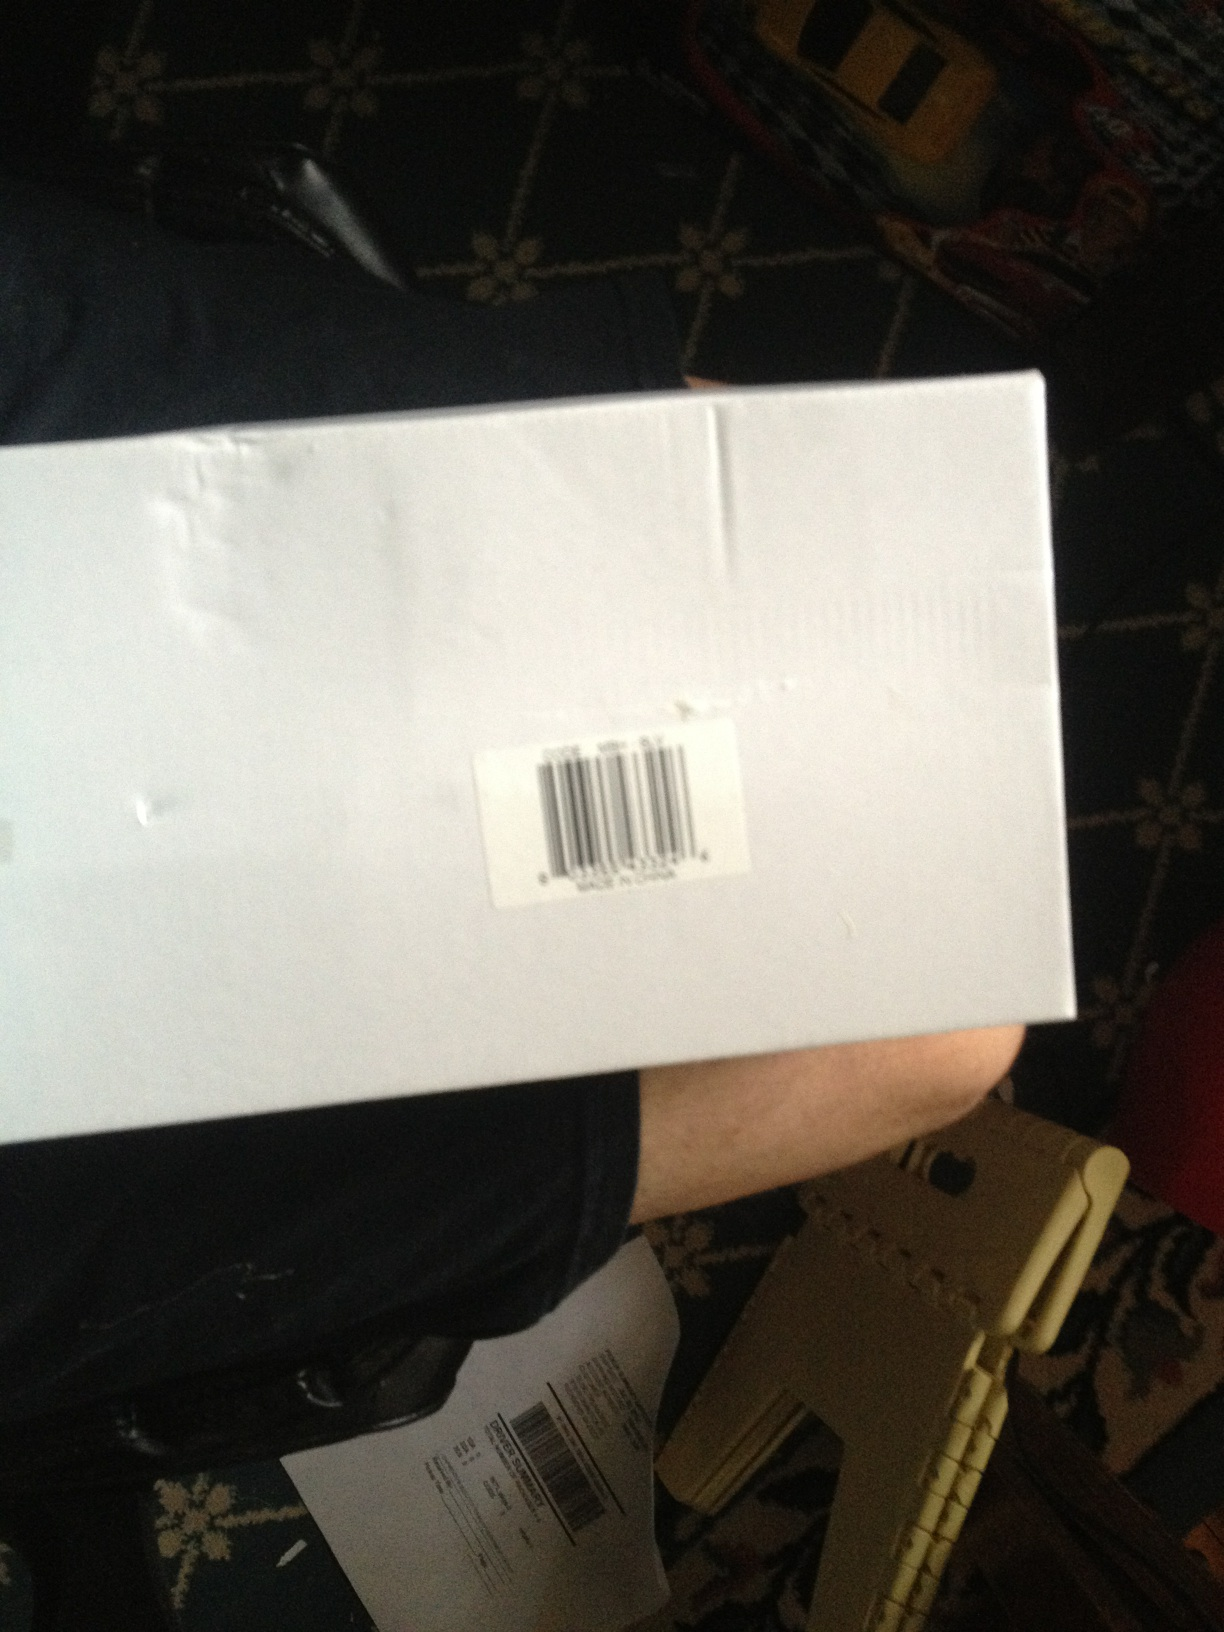Create a realistic scenario where this box is part of an important delivery. In a bustling metropolitan city, a high-profile event is fast approaching - the launch of a revolutionary new tech product. Amidst the chaos, an important prototype is missing. The clock ticks down, and the pressure mounts. Suddenly, a delivery person arrives at the headquarters with a white box bearing a barcode. Inside, neatly packed, is the critical prototype, saving the day just in time for the product unveiling.  Describe a situation where this box might be easily overlooked. In the back of a busy retail warehouse, dozens of identical white boxes are stacked high. Amid the constant hustle and bustle, a single box falls behind a shelf, unnoticed. It sits there, gathering dust, forgotten in the flurry of activity. Despite containing a crucial shipment of new inventory, its plain exterior ensures it blends in seamlessly with the multitude of other packages. 